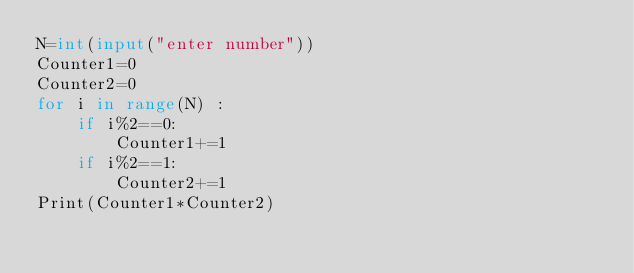<code> <loc_0><loc_0><loc_500><loc_500><_Python_>N=int(input("enter number")) 
Counter1=0
Counter2=0
for i in range(N) :
    if i%2==0:
        Counter1+=1 
    if i%2==1:
        Counter2+=1 
Print(Counter1*Counter2)</code> 